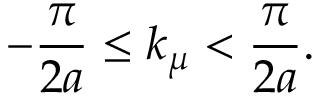Convert formula to latex. <formula><loc_0><loc_0><loc_500><loc_500>- \frac { \pi } { 2 a } \leq k _ { \mu } < \frac { \pi } { 2 a } .</formula> 